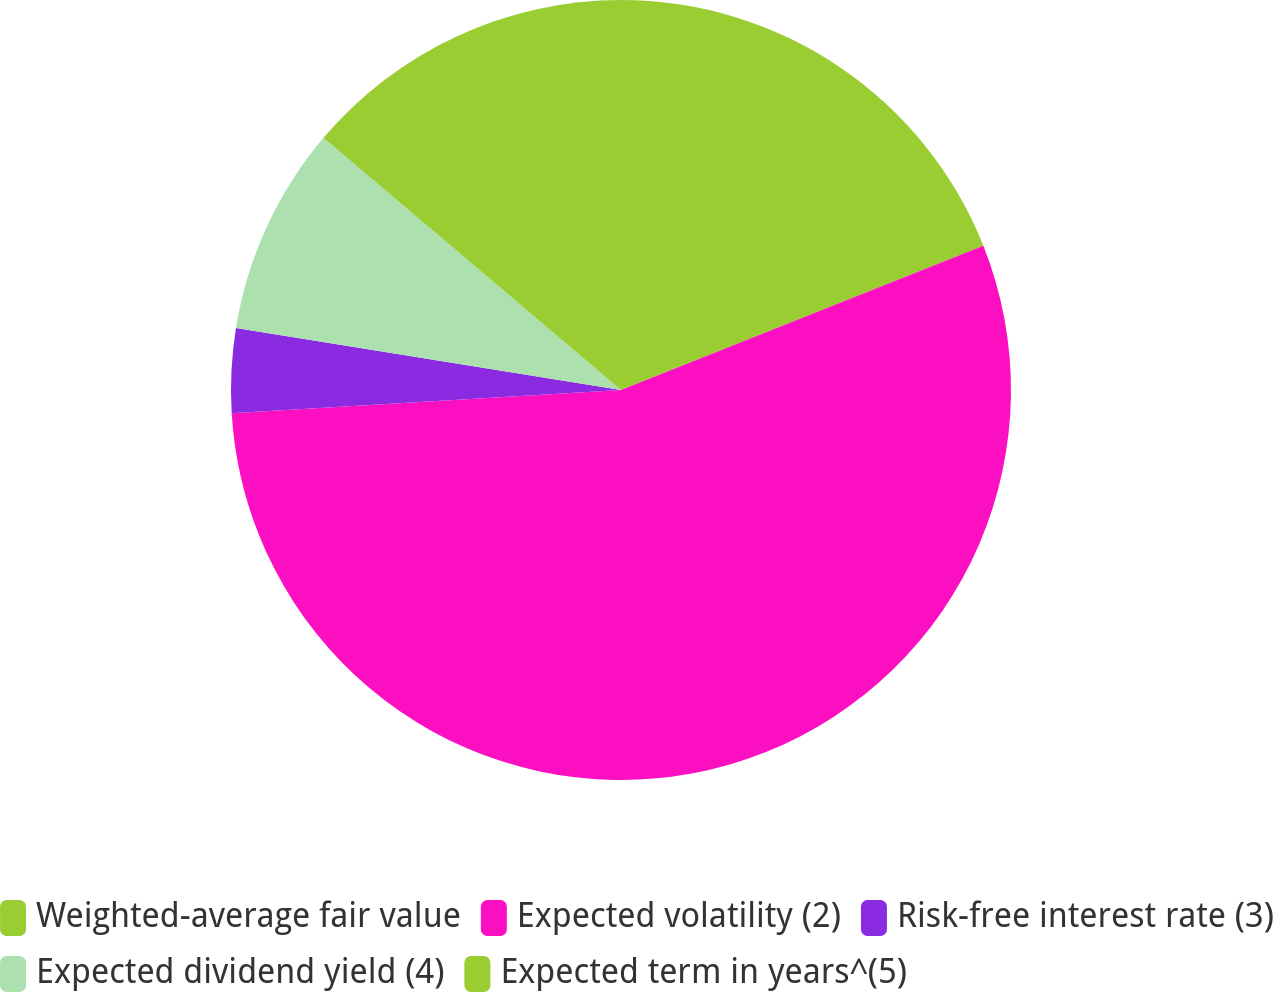Convert chart. <chart><loc_0><loc_0><loc_500><loc_500><pie_chart><fcel>Weighted-average fair value<fcel>Expected volatility (2)<fcel>Risk-free interest rate (3)<fcel>Expected dividend yield (4)<fcel>Expected term in years^(5)<nl><fcel>18.97%<fcel>55.08%<fcel>3.49%<fcel>8.65%<fcel>13.81%<nl></chart> 